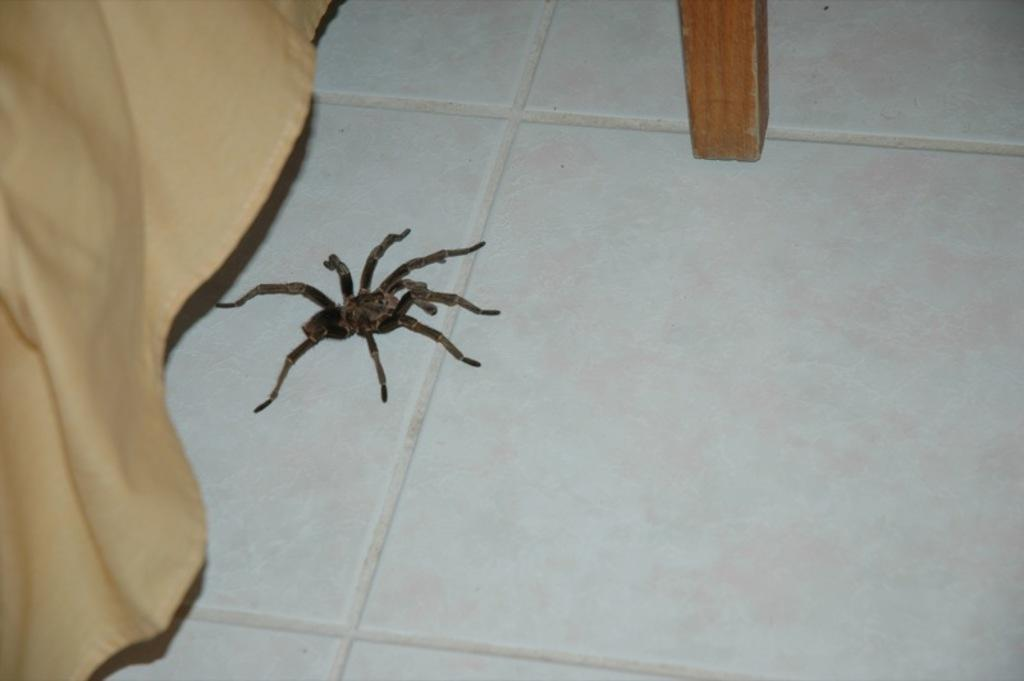What is on the floor in the image? There is a spider on the floor in the image. What else can be seen in the image besides the spider? There is a cloth and a wooden object in the image. What type of drink is the spider holding in the image? There is no drink present in the image, and the spider is not holding anything. 